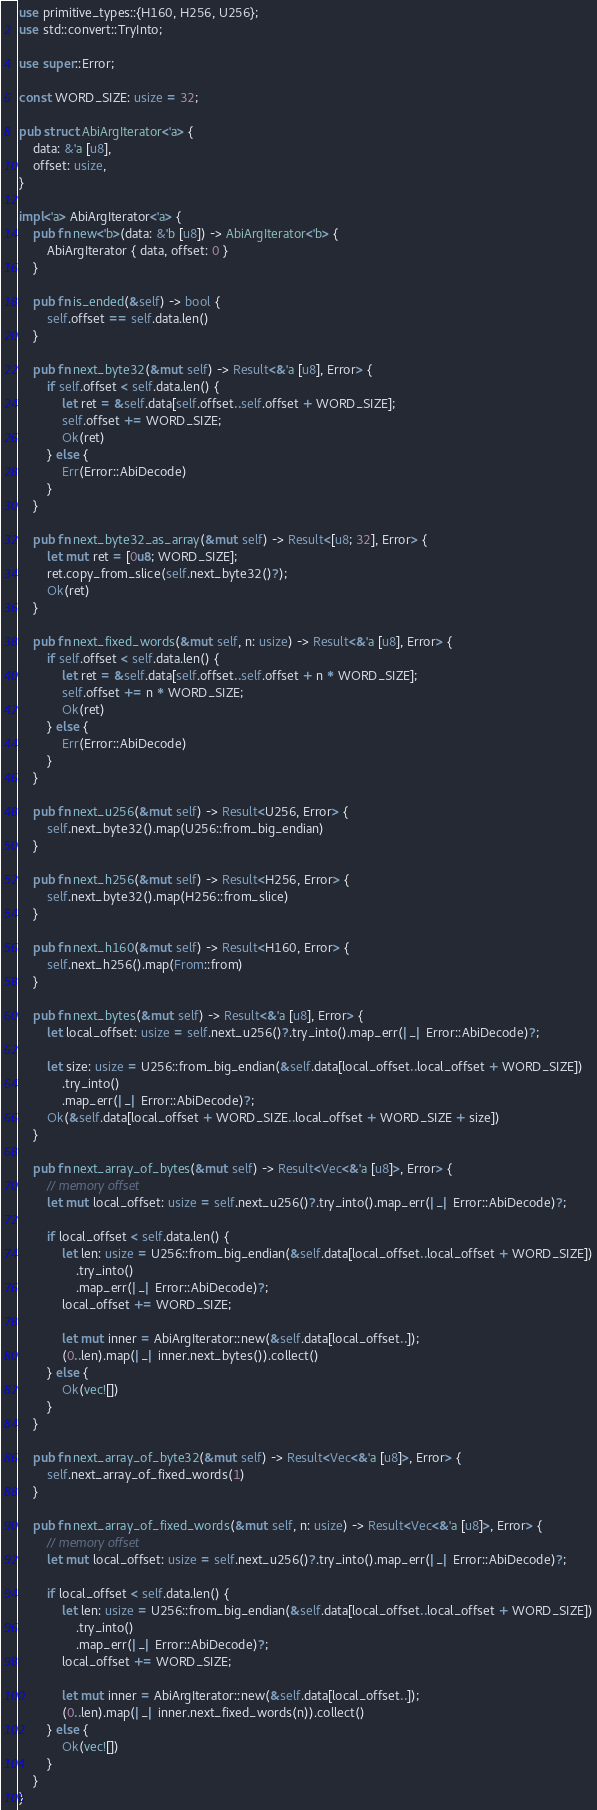<code> <loc_0><loc_0><loc_500><loc_500><_Rust_>use primitive_types::{H160, H256, U256};
use std::convert::TryInto;

use super::Error;

const WORD_SIZE: usize = 32;

pub struct AbiArgIterator<'a> {
    data: &'a [u8],
    offset: usize,
}

impl<'a> AbiArgIterator<'a> {
    pub fn new<'b>(data: &'b [u8]) -> AbiArgIterator<'b> {
        AbiArgIterator { data, offset: 0 }
    }

    pub fn is_ended(&self) -> bool {
        self.offset == self.data.len()
    }

    pub fn next_byte32(&mut self) -> Result<&'a [u8], Error> {
        if self.offset < self.data.len() {
            let ret = &self.data[self.offset..self.offset + WORD_SIZE];
            self.offset += WORD_SIZE;
            Ok(ret)
        } else {
            Err(Error::AbiDecode)
        }
    }

    pub fn next_byte32_as_array(&mut self) -> Result<[u8; 32], Error> {
        let mut ret = [0u8; WORD_SIZE];
        ret.copy_from_slice(self.next_byte32()?);
        Ok(ret)
    }

    pub fn next_fixed_words(&mut self, n: usize) -> Result<&'a [u8], Error> {
        if self.offset < self.data.len() {
            let ret = &self.data[self.offset..self.offset + n * WORD_SIZE];
            self.offset += n * WORD_SIZE;
            Ok(ret)
        } else {
            Err(Error::AbiDecode)
        }
    }

    pub fn next_u256(&mut self) -> Result<U256, Error> {
        self.next_byte32().map(U256::from_big_endian)
    }

    pub fn next_h256(&mut self) -> Result<H256, Error> {
        self.next_byte32().map(H256::from_slice)
    }

    pub fn next_h160(&mut self) -> Result<H160, Error> {
        self.next_h256().map(From::from)
    }

    pub fn next_bytes(&mut self) -> Result<&'a [u8], Error> {
        let local_offset: usize = self.next_u256()?.try_into().map_err(|_| Error::AbiDecode)?;

        let size: usize = U256::from_big_endian(&self.data[local_offset..local_offset + WORD_SIZE])
            .try_into()
            .map_err(|_| Error::AbiDecode)?;
        Ok(&self.data[local_offset + WORD_SIZE..local_offset + WORD_SIZE + size])
    }

    pub fn next_array_of_bytes(&mut self) -> Result<Vec<&'a [u8]>, Error> {
        // memory offset
        let mut local_offset: usize = self.next_u256()?.try_into().map_err(|_| Error::AbiDecode)?;

        if local_offset < self.data.len() {
            let len: usize = U256::from_big_endian(&self.data[local_offset..local_offset + WORD_SIZE])
                .try_into()
                .map_err(|_| Error::AbiDecode)?;
            local_offset += WORD_SIZE;

            let mut inner = AbiArgIterator::new(&self.data[local_offset..]);
            (0..len).map(|_| inner.next_bytes()).collect()
        } else {
            Ok(vec![])
        }
    }

    pub fn next_array_of_byte32(&mut self) -> Result<Vec<&'a [u8]>, Error> {
        self.next_array_of_fixed_words(1)
    }

    pub fn next_array_of_fixed_words(&mut self, n: usize) -> Result<Vec<&'a [u8]>, Error> {
        // memory offset
        let mut local_offset: usize = self.next_u256()?.try_into().map_err(|_| Error::AbiDecode)?;

        if local_offset < self.data.len() {
            let len: usize = U256::from_big_endian(&self.data[local_offset..local_offset + WORD_SIZE])
                .try_into()
                .map_err(|_| Error::AbiDecode)?;
            local_offset += WORD_SIZE;

            let mut inner = AbiArgIterator::new(&self.data[local_offset..]);
            (0..len).map(|_| inner.next_fixed_words(n)).collect()
        } else {
            Ok(vec![])
        }
    }
}
</code> 